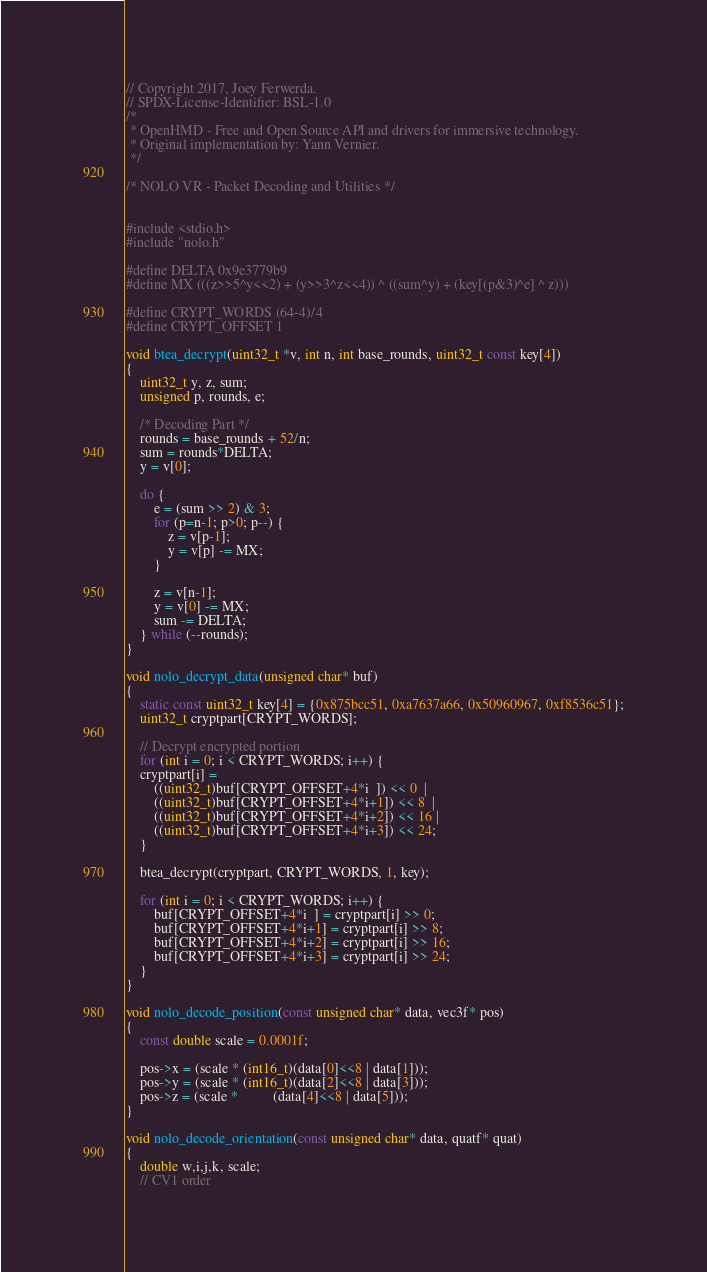<code> <loc_0><loc_0><loc_500><loc_500><_C_>// Copyright 2017, Joey Ferwerda.
// SPDX-License-Identifier: BSL-1.0
/*
 * OpenHMD - Free and Open Source API and drivers for immersive technology.
 * Original implementation by: Yann Vernier.
 */

/* NOLO VR - Packet Decoding and Utilities */


#include <stdio.h>
#include "nolo.h"

#define DELTA 0x9e3779b9
#define MX (((z>>5^y<<2) + (y>>3^z<<4)) ^ ((sum^y) + (key[(p&3)^e] ^ z)))

#define CRYPT_WORDS (64-4)/4
#define CRYPT_OFFSET 1

void btea_decrypt(uint32_t *v, int n, int base_rounds, uint32_t const key[4])
{
	uint32_t y, z, sum;
	unsigned p, rounds, e;

	/* Decoding Part */
	rounds = base_rounds + 52/n;
	sum = rounds*DELTA;
	y = v[0];

	do {
		e = (sum >> 2) & 3;
		for (p=n-1; p>0; p--) {
			z = v[p-1];
			y = v[p] -= MX;
		}

		z = v[n-1];
		y = v[0] -= MX;
		sum -= DELTA;
	} while (--rounds);
}

void nolo_decrypt_data(unsigned char* buf)
{
	static const uint32_t key[4] = {0x875bcc51, 0xa7637a66, 0x50960967, 0xf8536c51};
	uint32_t cryptpart[CRYPT_WORDS];

	// Decrypt encrypted portion
	for (int i = 0; i < CRYPT_WORDS; i++) {
	cryptpart[i] =
		((uint32_t)buf[CRYPT_OFFSET+4*i  ]) << 0  |
		((uint32_t)buf[CRYPT_OFFSET+4*i+1]) << 8  |
		((uint32_t)buf[CRYPT_OFFSET+4*i+2]) << 16 |
		((uint32_t)buf[CRYPT_OFFSET+4*i+3]) << 24;
	}

	btea_decrypt(cryptpart, CRYPT_WORDS, 1, key);

	for (int i = 0; i < CRYPT_WORDS; i++) {
		buf[CRYPT_OFFSET+4*i  ] = cryptpart[i] >> 0;
		buf[CRYPT_OFFSET+4*i+1] = cryptpart[i] >> 8;
		buf[CRYPT_OFFSET+4*i+2] = cryptpart[i] >> 16;
		buf[CRYPT_OFFSET+4*i+3] = cryptpart[i] >> 24;
	}
}

void nolo_decode_position(const unsigned char* data, vec3f* pos)
{
	const double scale = 0.0001f;

	pos->x = (scale * (int16_t)(data[0]<<8 | data[1]));
	pos->y = (scale * (int16_t)(data[2]<<8 | data[3]));
	pos->z = (scale *          (data[4]<<8 | data[5]));
}

void nolo_decode_orientation(const unsigned char* data, quatf* quat)
{
	double w,i,j,k, scale;
	// CV1 order</code> 